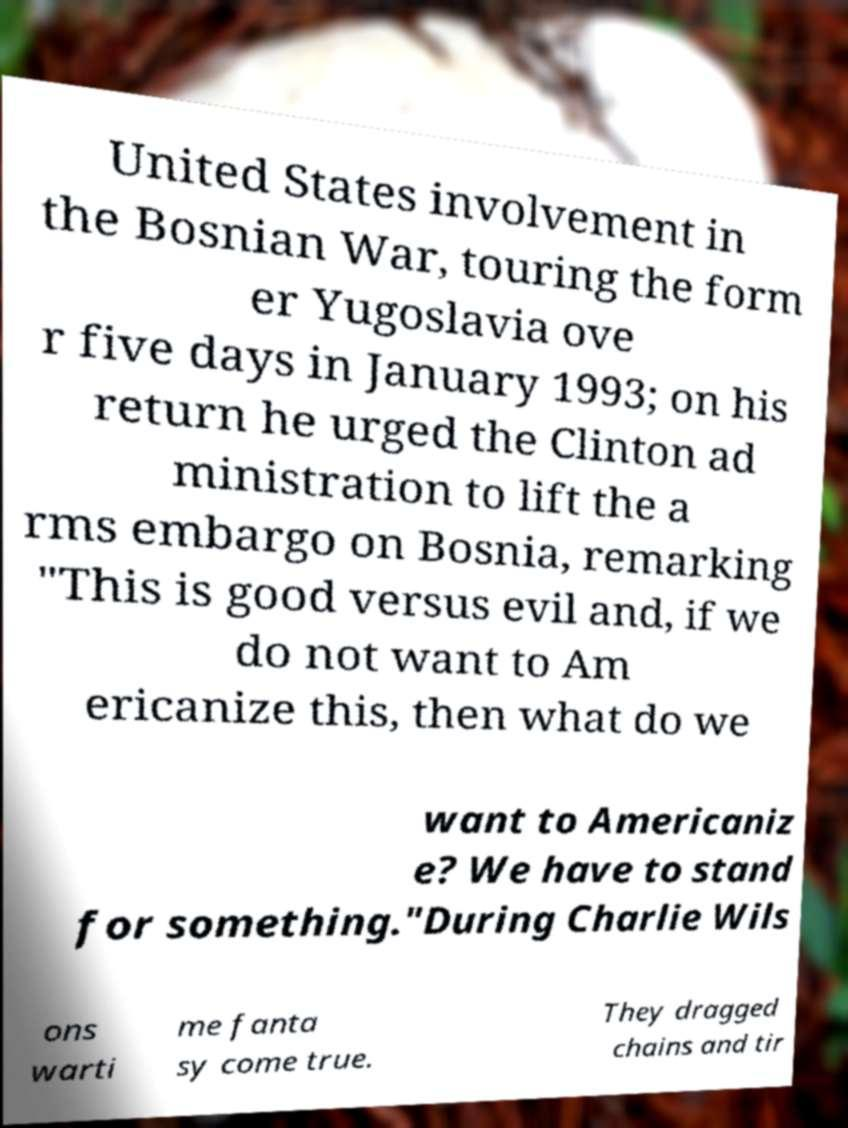Can you accurately transcribe the text from the provided image for me? United States involvement in the Bosnian War, touring the form er Yugoslavia ove r five days in January 1993; on his return he urged the Clinton ad ministration to lift the a rms embargo on Bosnia, remarking "This is good versus evil and, if we do not want to Am ericanize this, then what do we want to Americaniz e? We have to stand for something."During Charlie Wils ons warti me fanta sy come true. They dragged chains and tir 